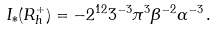Convert formula to latex. <formula><loc_0><loc_0><loc_500><loc_500>I _ { * } ( R _ { h } ^ { + } ) = - 2 ^ { 1 2 } 3 ^ { - 3 } \pi ^ { 3 } \beta ^ { - 2 } \alpha ^ { - 3 } \, .</formula> 